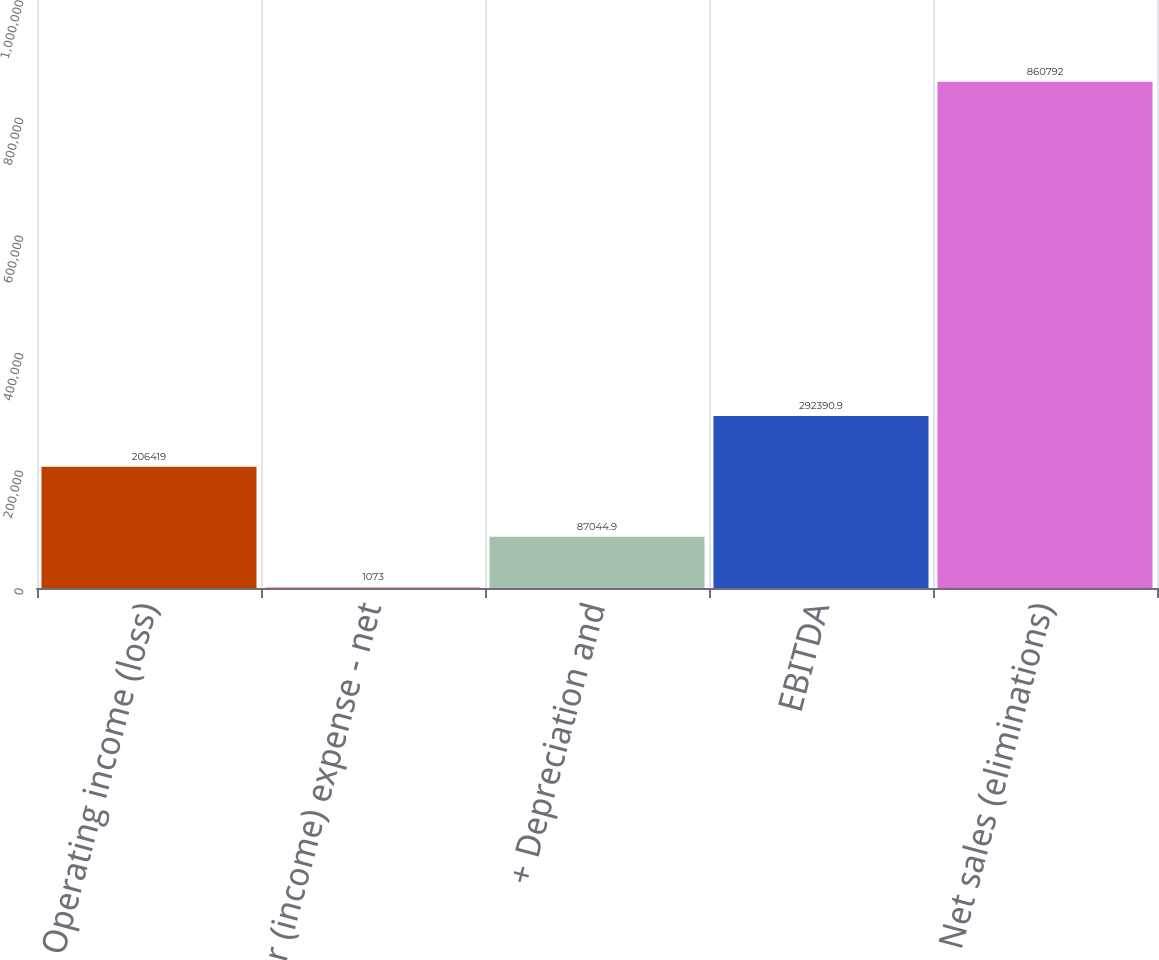Convert chart to OTSL. <chart><loc_0><loc_0><loc_500><loc_500><bar_chart><fcel>Operating income (loss)<fcel>- Other (income) expense - net<fcel>+ Depreciation and<fcel>EBITDA<fcel>Net sales (eliminations)<nl><fcel>206419<fcel>1073<fcel>87044.9<fcel>292391<fcel>860792<nl></chart> 